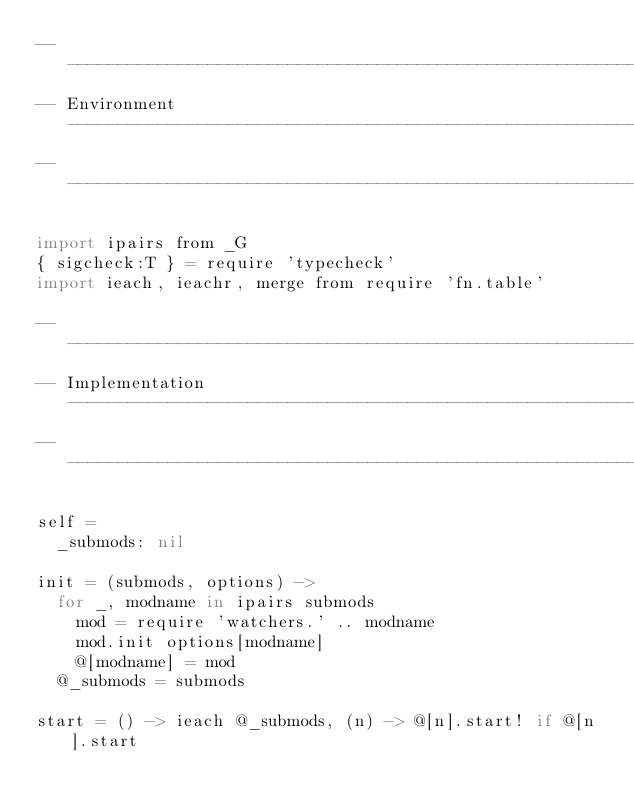Convert code to text. <code><loc_0><loc_0><loc_500><loc_500><_MoonScript_>---------------------------------------------------------------------------
-- Environment ------------------------------------------------------------
---------------------------------------------------------------------------

import ipairs from _G
{ sigcheck:T } = require 'typecheck'
import ieach, ieachr, merge from require 'fn.table'

---------------------------------------------------------------------------
-- Implementation ---------------------------------------------------------
---------------------------------------------------------------------------

self =
  _submods: nil

init = (submods, options) ->
  for _, modname in ipairs submods
    mod = require 'watchers.' .. modname
    mod.init options[modname]
    @[modname] = mod
  @_submods = submods

start = () -> ieach @_submods, (n) -> @[n].start! if @[n].start
  </code> 